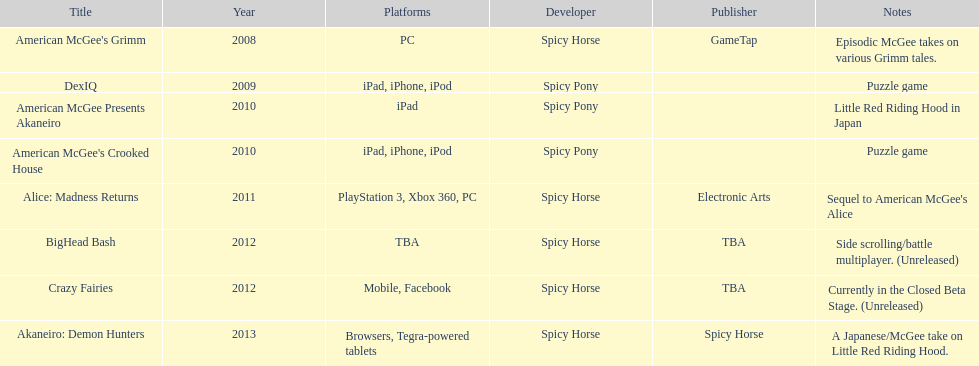How many games did spicy horse develop in total? 5. 